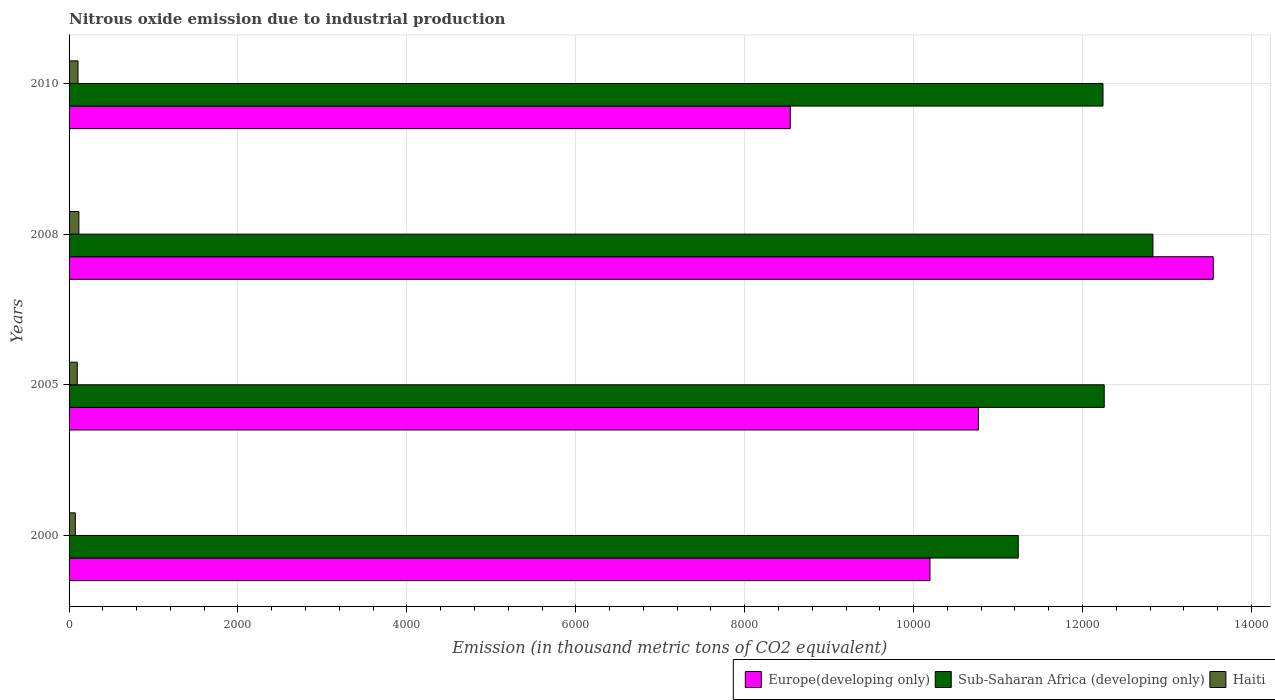Are the number of bars per tick equal to the number of legend labels?
Offer a very short reply. Yes. In how many cases, is the number of bars for a given year not equal to the number of legend labels?
Your response must be concise. 0. What is the amount of nitrous oxide emitted in Europe(developing only) in 2010?
Your answer should be very brief. 8539.4. Across all years, what is the maximum amount of nitrous oxide emitted in Sub-Saharan Africa (developing only)?
Provide a short and direct response. 1.28e+04. Across all years, what is the minimum amount of nitrous oxide emitted in Europe(developing only)?
Your response must be concise. 8539.4. In which year was the amount of nitrous oxide emitted in Haiti maximum?
Offer a terse response. 2008. What is the total amount of nitrous oxide emitted in Europe(developing only) in the graph?
Provide a succinct answer. 4.30e+04. What is the difference between the amount of nitrous oxide emitted in Europe(developing only) in 2008 and that in 2010?
Your response must be concise. 5008.6. What is the difference between the amount of nitrous oxide emitted in Haiti in 2000 and the amount of nitrous oxide emitted in Sub-Saharan Africa (developing only) in 2008?
Provide a succinct answer. -1.28e+04. What is the average amount of nitrous oxide emitted in Sub-Saharan Africa (developing only) per year?
Provide a short and direct response. 1.21e+04. In the year 2005, what is the difference between the amount of nitrous oxide emitted in Sub-Saharan Africa (developing only) and amount of nitrous oxide emitted in Europe(developing only)?
Provide a short and direct response. 1489.4. What is the ratio of the amount of nitrous oxide emitted in Sub-Saharan Africa (developing only) in 2000 to that in 2010?
Keep it short and to the point. 0.92. Is the amount of nitrous oxide emitted in Europe(developing only) in 2000 less than that in 2008?
Give a very brief answer. Yes. Is the difference between the amount of nitrous oxide emitted in Sub-Saharan Africa (developing only) in 2005 and 2008 greater than the difference between the amount of nitrous oxide emitted in Europe(developing only) in 2005 and 2008?
Keep it short and to the point. Yes. What is the difference between the highest and the second highest amount of nitrous oxide emitted in Europe(developing only)?
Keep it short and to the point. 2780.6. What is the difference between the highest and the lowest amount of nitrous oxide emitted in Sub-Saharan Africa (developing only)?
Keep it short and to the point. 1594.7. In how many years, is the amount of nitrous oxide emitted in Haiti greater than the average amount of nitrous oxide emitted in Haiti taken over all years?
Your answer should be compact. 2. Is the sum of the amount of nitrous oxide emitted in Haiti in 2000 and 2008 greater than the maximum amount of nitrous oxide emitted in Europe(developing only) across all years?
Provide a succinct answer. No. What does the 3rd bar from the top in 2000 represents?
Provide a succinct answer. Europe(developing only). What does the 2nd bar from the bottom in 2008 represents?
Ensure brevity in your answer.  Sub-Saharan Africa (developing only). Is it the case that in every year, the sum of the amount of nitrous oxide emitted in Europe(developing only) and amount of nitrous oxide emitted in Sub-Saharan Africa (developing only) is greater than the amount of nitrous oxide emitted in Haiti?
Give a very brief answer. Yes. How many bars are there?
Your response must be concise. 12. What is the difference between two consecutive major ticks on the X-axis?
Your answer should be very brief. 2000. Does the graph contain any zero values?
Make the answer very short. No. Where does the legend appear in the graph?
Provide a succinct answer. Bottom right. How are the legend labels stacked?
Your answer should be very brief. Horizontal. What is the title of the graph?
Your answer should be compact. Nitrous oxide emission due to industrial production. What is the label or title of the X-axis?
Provide a succinct answer. Emission (in thousand metric tons of CO2 equivalent). What is the Emission (in thousand metric tons of CO2 equivalent) of Europe(developing only) in 2000?
Keep it short and to the point. 1.02e+04. What is the Emission (in thousand metric tons of CO2 equivalent) in Sub-Saharan Africa (developing only) in 2000?
Offer a very short reply. 1.12e+04. What is the Emission (in thousand metric tons of CO2 equivalent) of Haiti in 2000?
Offer a very short reply. 73.8. What is the Emission (in thousand metric tons of CO2 equivalent) of Europe(developing only) in 2005?
Make the answer very short. 1.08e+04. What is the Emission (in thousand metric tons of CO2 equivalent) in Sub-Saharan Africa (developing only) in 2005?
Offer a very short reply. 1.23e+04. What is the Emission (in thousand metric tons of CO2 equivalent) in Haiti in 2005?
Ensure brevity in your answer.  97. What is the Emission (in thousand metric tons of CO2 equivalent) in Europe(developing only) in 2008?
Keep it short and to the point. 1.35e+04. What is the Emission (in thousand metric tons of CO2 equivalent) in Sub-Saharan Africa (developing only) in 2008?
Offer a terse response. 1.28e+04. What is the Emission (in thousand metric tons of CO2 equivalent) of Haiti in 2008?
Keep it short and to the point. 116. What is the Emission (in thousand metric tons of CO2 equivalent) in Europe(developing only) in 2010?
Offer a very short reply. 8539.4. What is the Emission (in thousand metric tons of CO2 equivalent) in Sub-Saharan Africa (developing only) in 2010?
Ensure brevity in your answer.  1.22e+04. What is the Emission (in thousand metric tons of CO2 equivalent) in Haiti in 2010?
Your response must be concise. 105.8. Across all years, what is the maximum Emission (in thousand metric tons of CO2 equivalent) of Europe(developing only)?
Provide a short and direct response. 1.35e+04. Across all years, what is the maximum Emission (in thousand metric tons of CO2 equivalent) in Sub-Saharan Africa (developing only)?
Your answer should be compact. 1.28e+04. Across all years, what is the maximum Emission (in thousand metric tons of CO2 equivalent) of Haiti?
Ensure brevity in your answer.  116. Across all years, what is the minimum Emission (in thousand metric tons of CO2 equivalent) of Europe(developing only)?
Provide a short and direct response. 8539.4. Across all years, what is the minimum Emission (in thousand metric tons of CO2 equivalent) in Sub-Saharan Africa (developing only)?
Your response must be concise. 1.12e+04. Across all years, what is the minimum Emission (in thousand metric tons of CO2 equivalent) of Haiti?
Offer a terse response. 73.8. What is the total Emission (in thousand metric tons of CO2 equivalent) of Europe(developing only) in the graph?
Provide a succinct answer. 4.30e+04. What is the total Emission (in thousand metric tons of CO2 equivalent) in Sub-Saharan Africa (developing only) in the graph?
Offer a terse response. 4.86e+04. What is the total Emission (in thousand metric tons of CO2 equivalent) of Haiti in the graph?
Offer a very short reply. 392.6. What is the difference between the Emission (in thousand metric tons of CO2 equivalent) in Europe(developing only) in 2000 and that in 2005?
Keep it short and to the point. -574. What is the difference between the Emission (in thousand metric tons of CO2 equivalent) in Sub-Saharan Africa (developing only) in 2000 and that in 2005?
Provide a succinct answer. -1018.1. What is the difference between the Emission (in thousand metric tons of CO2 equivalent) in Haiti in 2000 and that in 2005?
Offer a terse response. -23.2. What is the difference between the Emission (in thousand metric tons of CO2 equivalent) in Europe(developing only) in 2000 and that in 2008?
Make the answer very short. -3354.6. What is the difference between the Emission (in thousand metric tons of CO2 equivalent) in Sub-Saharan Africa (developing only) in 2000 and that in 2008?
Offer a very short reply. -1594.7. What is the difference between the Emission (in thousand metric tons of CO2 equivalent) of Haiti in 2000 and that in 2008?
Your response must be concise. -42.2. What is the difference between the Emission (in thousand metric tons of CO2 equivalent) of Europe(developing only) in 2000 and that in 2010?
Offer a terse response. 1654. What is the difference between the Emission (in thousand metric tons of CO2 equivalent) of Sub-Saharan Africa (developing only) in 2000 and that in 2010?
Give a very brief answer. -1003.5. What is the difference between the Emission (in thousand metric tons of CO2 equivalent) of Haiti in 2000 and that in 2010?
Your answer should be very brief. -32. What is the difference between the Emission (in thousand metric tons of CO2 equivalent) in Europe(developing only) in 2005 and that in 2008?
Ensure brevity in your answer.  -2780.6. What is the difference between the Emission (in thousand metric tons of CO2 equivalent) in Sub-Saharan Africa (developing only) in 2005 and that in 2008?
Make the answer very short. -576.6. What is the difference between the Emission (in thousand metric tons of CO2 equivalent) in Haiti in 2005 and that in 2008?
Make the answer very short. -19. What is the difference between the Emission (in thousand metric tons of CO2 equivalent) in Europe(developing only) in 2005 and that in 2010?
Your answer should be very brief. 2228. What is the difference between the Emission (in thousand metric tons of CO2 equivalent) in Europe(developing only) in 2008 and that in 2010?
Offer a very short reply. 5008.6. What is the difference between the Emission (in thousand metric tons of CO2 equivalent) of Sub-Saharan Africa (developing only) in 2008 and that in 2010?
Give a very brief answer. 591.2. What is the difference between the Emission (in thousand metric tons of CO2 equivalent) in Haiti in 2008 and that in 2010?
Provide a short and direct response. 10.2. What is the difference between the Emission (in thousand metric tons of CO2 equivalent) in Europe(developing only) in 2000 and the Emission (in thousand metric tons of CO2 equivalent) in Sub-Saharan Africa (developing only) in 2005?
Offer a terse response. -2063.4. What is the difference between the Emission (in thousand metric tons of CO2 equivalent) of Europe(developing only) in 2000 and the Emission (in thousand metric tons of CO2 equivalent) of Haiti in 2005?
Your answer should be compact. 1.01e+04. What is the difference between the Emission (in thousand metric tons of CO2 equivalent) in Sub-Saharan Africa (developing only) in 2000 and the Emission (in thousand metric tons of CO2 equivalent) in Haiti in 2005?
Keep it short and to the point. 1.11e+04. What is the difference between the Emission (in thousand metric tons of CO2 equivalent) of Europe(developing only) in 2000 and the Emission (in thousand metric tons of CO2 equivalent) of Sub-Saharan Africa (developing only) in 2008?
Keep it short and to the point. -2640. What is the difference between the Emission (in thousand metric tons of CO2 equivalent) in Europe(developing only) in 2000 and the Emission (in thousand metric tons of CO2 equivalent) in Haiti in 2008?
Your answer should be compact. 1.01e+04. What is the difference between the Emission (in thousand metric tons of CO2 equivalent) of Sub-Saharan Africa (developing only) in 2000 and the Emission (in thousand metric tons of CO2 equivalent) of Haiti in 2008?
Ensure brevity in your answer.  1.11e+04. What is the difference between the Emission (in thousand metric tons of CO2 equivalent) of Europe(developing only) in 2000 and the Emission (in thousand metric tons of CO2 equivalent) of Sub-Saharan Africa (developing only) in 2010?
Offer a terse response. -2048.8. What is the difference between the Emission (in thousand metric tons of CO2 equivalent) in Europe(developing only) in 2000 and the Emission (in thousand metric tons of CO2 equivalent) in Haiti in 2010?
Ensure brevity in your answer.  1.01e+04. What is the difference between the Emission (in thousand metric tons of CO2 equivalent) in Sub-Saharan Africa (developing only) in 2000 and the Emission (in thousand metric tons of CO2 equivalent) in Haiti in 2010?
Provide a short and direct response. 1.11e+04. What is the difference between the Emission (in thousand metric tons of CO2 equivalent) of Europe(developing only) in 2005 and the Emission (in thousand metric tons of CO2 equivalent) of Sub-Saharan Africa (developing only) in 2008?
Provide a succinct answer. -2066. What is the difference between the Emission (in thousand metric tons of CO2 equivalent) of Europe(developing only) in 2005 and the Emission (in thousand metric tons of CO2 equivalent) of Haiti in 2008?
Your response must be concise. 1.07e+04. What is the difference between the Emission (in thousand metric tons of CO2 equivalent) in Sub-Saharan Africa (developing only) in 2005 and the Emission (in thousand metric tons of CO2 equivalent) in Haiti in 2008?
Ensure brevity in your answer.  1.21e+04. What is the difference between the Emission (in thousand metric tons of CO2 equivalent) in Europe(developing only) in 2005 and the Emission (in thousand metric tons of CO2 equivalent) in Sub-Saharan Africa (developing only) in 2010?
Provide a short and direct response. -1474.8. What is the difference between the Emission (in thousand metric tons of CO2 equivalent) of Europe(developing only) in 2005 and the Emission (in thousand metric tons of CO2 equivalent) of Haiti in 2010?
Provide a short and direct response. 1.07e+04. What is the difference between the Emission (in thousand metric tons of CO2 equivalent) in Sub-Saharan Africa (developing only) in 2005 and the Emission (in thousand metric tons of CO2 equivalent) in Haiti in 2010?
Offer a very short reply. 1.22e+04. What is the difference between the Emission (in thousand metric tons of CO2 equivalent) of Europe(developing only) in 2008 and the Emission (in thousand metric tons of CO2 equivalent) of Sub-Saharan Africa (developing only) in 2010?
Provide a short and direct response. 1305.8. What is the difference between the Emission (in thousand metric tons of CO2 equivalent) of Europe(developing only) in 2008 and the Emission (in thousand metric tons of CO2 equivalent) of Haiti in 2010?
Give a very brief answer. 1.34e+04. What is the difference between the Emission (in thousand metric tons of CO2 equivalent) in Sub-Saharan Africa (developing only) in 2008 and the Emission (in thousand metric tons of CO2 equivalent) in Haiti in 2010?
Ensure brevity in your answer.  1.27e+04. What is the average Emission (in thousand metric tons of CO2 equivalent) in Europe(developing only) per year?
Provide a succinct answer. 1.08e+04. What is the average Emission (in thousand metric tons of CO2 equivalent) of Sub-Saharan Africa (developing only) per year?
Your answer should be compact. 1.21e+04. What is the average Emission (in thousand metric tons of CO2 equivalent) of Haiti per year?
Your answer should be compact. 98.15. In the year 2000, what is the difference between the Emission (in thousand metric tons of CO2 equivalent) in Europe(developing only) and Emission (in thousand metric tons of CO2 equivalent) in Sub-Saharan Africa (developing only)?
Give a very brief answer. -1045.3. In the year 2000, what is the difference between the Emission (in thousand metric tons of CO2 equivalent) of Europe(developing only) and Emission (in thousand metric tons of CO2 equivalent) of Haiti?
Provide a succinct answer. 1.01e+04. In the year 2000, what is the difference between the Emission (in thousand metric tons of CO2 equivalent) of Sub-Saharan Africa (developing only) and Emission (in thousand metric tons of CO2 equivalent) of Haiti?
Keep it short and to the point. 1.12e+04. In the year 2005, what is the difference between the Emission (in thousand metric tons of CO2 equivalent) of Europe(developing only) and Emission (in thousand metric tons of CO2 equivalent) of Sub-Saharan Africa (developing only)?
Your answer should be very brief. -1489.4. In the year 2005, what is the difference between the Emission (in thousand metric tons of CO2 equivalent) in Europe(developing only) and Emission (in thousand metric tons of CO2 equivalent) in Haiti?
Offer a very short reply. 1.07e+04. In the year 2005, what is the difference between the Emission (in thousand metric tons of CO2 equivalent) in Sub-Saharan Africa (developing only) and Emission (in thousand metric tons of CO2 equivalent) in Haiti?
Offer a very short reply. 1.22e+04. In the year 2008, what is the difference between the Emission (in thousand metric tons of CO2 equivalent) in Europe(developing only) and Emission (in thousand metric tons of CO2 equivalent) in Sub-Saharan Africa (developing only)?
Provide a succinct answer. 714.6. In the year 2008, what is the difference between the Emission (in thousand metric tons of CO2 equivalent) of Europe(developing only) and Emission (in thousand metric tons of CO2 equivalent) of Haiti?
Provide a succinct answer. 1.34e+04. In the year 2008, what is the difference between the Emission (in thousand metric tons of CO2 equivalent) of Sub-Saharan Africa (developing only) and Emission (in thousand metric tons of CO2 equivalent) of Haiti?
Make the answer very short. 1.27e+04. In the year 2010, what is the difference between the Emission (in thousand metric tons of CO2 equivalent) in Europe(developing only) and Emission (in thousand metric tons of CO2 equivalent) in Sub-Saharan Africa (developing only)?
Give a very brief answer. -3702.8. In the year 2010, what is the difference between the Emission (in thousand metric tons of CO2 equivalent) in Europe(developing only) and Emission (in thousand metric tons of CO2 equivalent) in Haiti?
Your answer should be compact. 8433.6. In the year 2010, what is the difference between the Emission (in thousand metric tons of CO2 equivalent) of Sub-Saharan Africa (developing only) and Emission (in thousand metric tons of CO2 equivalent) of Haiti?
Keep it short and to the point. 1.21e+04. What is the ratio of the Emission (in thousand metric tons of CO2 equivalent) in Europe(developing only) in 2000 to that in 2005?
Give a very brief answer. 0.95. What is the ratio of the Emission (in thousand metric tons of CO2 equivalent) in Sub-Saharan Africa (developing only) in 2000 to that in 2005?
Offer a terse response. 0.92. What is the ratio of the Emission (in thousand metric tons of CO2 equivalent) in Haiti in 2000 to that in 2005?
Keep it short and to the point. 0.76. What is the ratio of the Emission (in thousand metric tons of CO2 equivalent) of Europe(developing only) in 2000 to that in 2008?
Make the answer very short. 0.75. What is the ratio of the Emission (in thousand metric tons of CO2 equivalent) of Sub-Saharan Africa (developing only) in 2000 to that in 2008?
Make the answer very short. 0.88. What is the ratio of the Emission (in thousand metric tons of CO2 equivalent) of Haiti in 2000 to that in 2008?
Provide a succinct answer. 0.64. What is the ratio of the Emission (in thousand metric tons of CO2 equivalent) of Europe(developing only) in 2000 to that in 2010?
Ensure brevity in your answer.  1.19. What is the ratio of the Emission (in thousand metric tons of CO2 equivalent) in Sub-Saharan Africa (developing only) in 2000 to that in 2010?
Provide a succinct answer. 0.92. What is the ratio of the Emission (in thousand metric tons of CO2 equivalent) in Haiti in 2000 to that in 2010?
Make the answer very short. 0.7. What is the ratio of the Emission (in thousand metric tons of CO2 equivalent) in Europe(developing only) in 2005 to that in 2008?
Ensure brevity in your answer.  0.79. What is the ratio of the Emission (in thousand metric tons of CO2 equivalent) in Sub-Saharan Africa (developing only) in 2005 to that in 2008?
Offer a very short reply. 0.96. What is the ratio of the Emission (in thousand metric tons of CO2 equivalent) in Haiti in 2005 to that in 2008?
Give a very brief answer. 0.84. What is the ratio of the Emission (in thousand metric tons of CO2 equivalent) in Europe(developing only) in 2005 to that in 2010?
Give a very brief answer. 1.26. What is the ratio of the Emission (in thousand metric tons of CO2 equivalent) of Haiti in 2005 to that in 2010?
Offer a very short reply. 0.92. What is the ratio of the Emission (in thousand metric tons of CO2 equivalent) in Europe(developing only) in 2008 to that in 2010?
Provide a succinct answer. 1.59. What is the ratio of the Emission (in thousand metric tons of CO2 equivalent) in Sub-Saharan Africa (developing only) in 2008 to that in 2010?
Your answer should be compact. 1.05. What is the ratio of the Emission (in thousand metric tons of CO2 equivalent) in Haiti in 2008 to that in 2010?
Your response must be concise. 1.1. What is the difference between the highest and the second highest Emission (in thousand metric tons of CO2 equivalent) in Europe(developing only)?
Your response must be concise. 2780.6. What is the difference between the highest and the second highest Emission (in thousand metric tons of CO2 equivalent) of Sub-Saharan Africa (developing only)?
Your response must be concise. 576.6. What is the difference between the highest and the lowest Emission (in thousand metric tons of CO2 equivalent) of Europe(developing only)?
Ensure brevity in your answer.  5008.6. What is the difference between the highest and the lowest Emission (in thousand metric tons of CO2 equivalent) in Sub-Saharan Africa (developing only)?
Your answer should be compact. 1594.7. What is the difference between the highest and the lowest Emission (in thousand metric tons of CO2 equivalent) in Haiti?
Your answer should be compact. 42.2. 